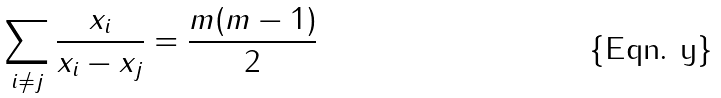<formula> <loc_0><loc_0><loc_500><loc_500>\sum _ { i \neq j } \frac { x _ { i } } { x _ { i } - x _ { j } } = \frac { m ( m - 1 ) } { 2 }</formula> 